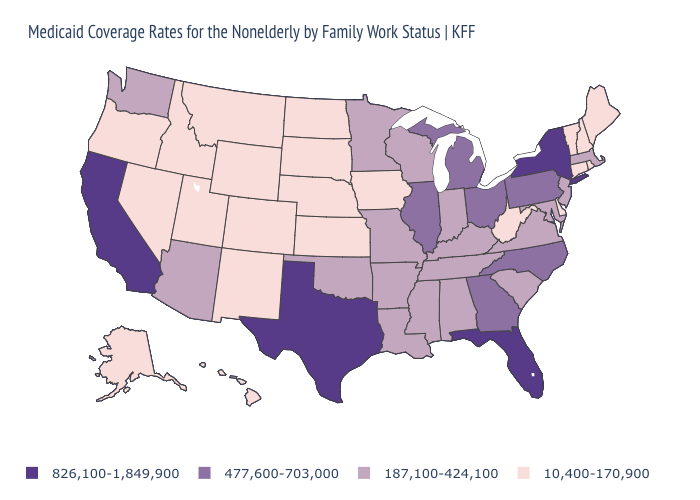Does New York have the highest value in the Northeast?
Concise answer only. Yes. Name the states that have a value in the range 187,100-424,100?
Be succinct. Alabama, Arizona, Arkansas, Indiana, Kentucky, Louisiana, Maryland, Massachusetts, Minnesota, Mississippi, Missouri, New Jersey, Oklahoma, South Carolina, Tennessee, Virginia, Washington, Wisconsin. What is the lowest value in the USA?
Short answer required. 10,400-170,900. What is the value of Louisiana?
Concise answer only. 187,100-424,100. Among the states that border Oregon , does California have the lowest value?
Answer briefly. No. Among the states that border Maryland , which have the lowest value?
Short answer required. Delaware, West Virginia. Name the states that have a value in the range 477,600-703,000?
Keep it brief. Georgia, Illinois, Michigan, North Carolina, Ohio, Pennsylvania. What is the highest value in the USA?
Quick response, please. 826,100-1,849,900. How many symbols are there in the legend?
Give a very brief answer. 4. Does Florida have a lower value than New Jersey?
Quick response, please. No. What is the value of New Mexico?
Write a very short answer. 10,400-170,900. What is the value of New Jersey?
Concise answer only. 187,100-424,100. Name the states that have a value in the range 826,100-1,849,900?
Short answer required. California, Florida, New York, Texas. Is the legend a continuous bar?
Keep it brief. No. What is the value of Colorado?
Concise answer only. 10,400-170,900. 